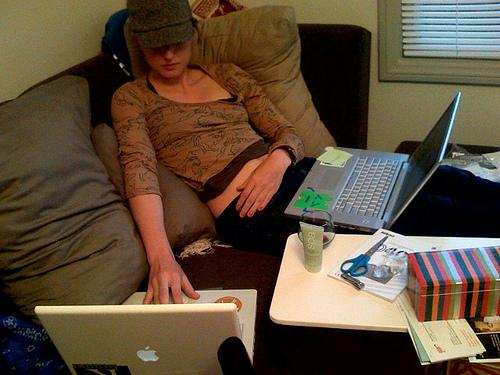Which item might she use on her skin? lotion 